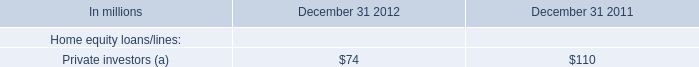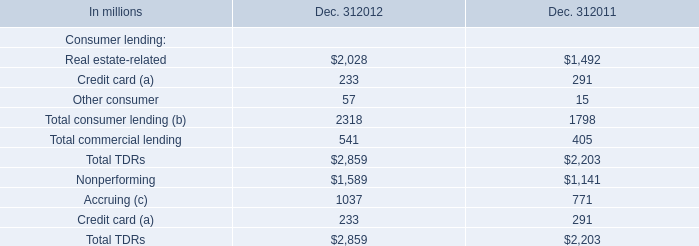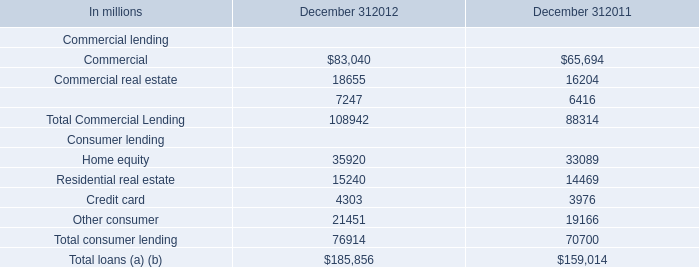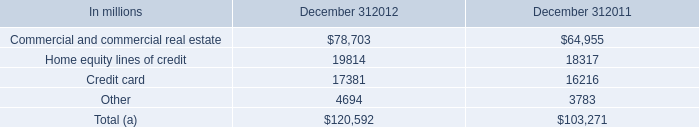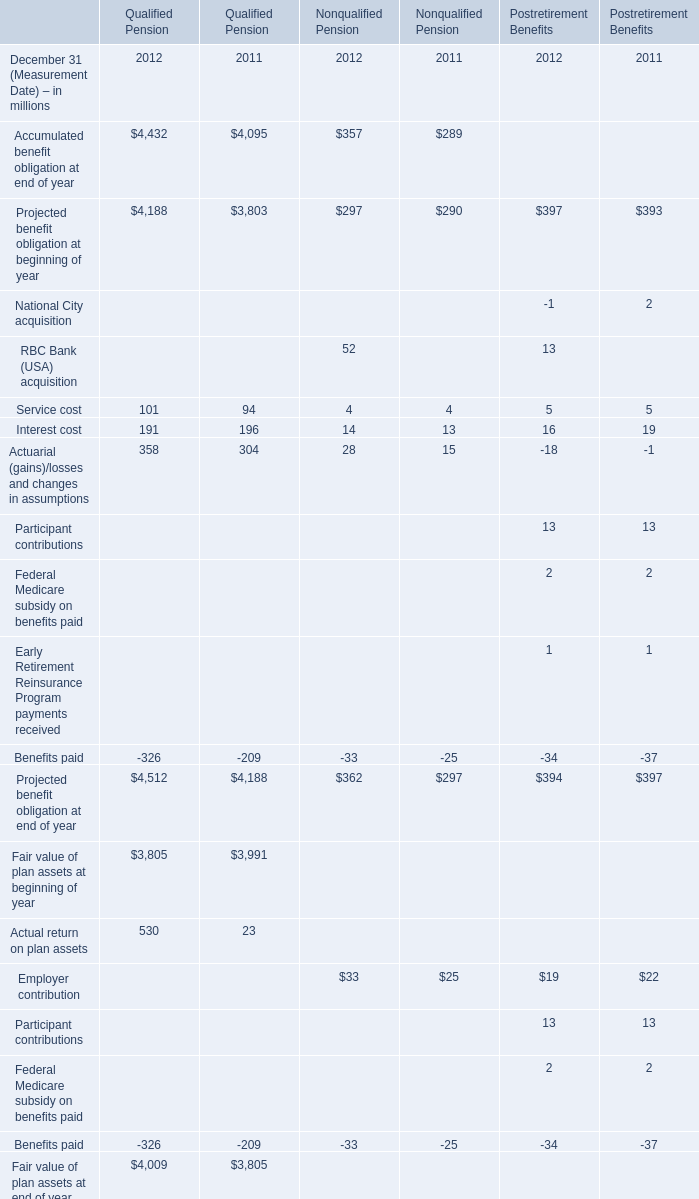What's the current increasing rate of Interest cost for Qualified Pension? 
Computations: ((191 - 196) / 196)
Answer: -0.02551. 